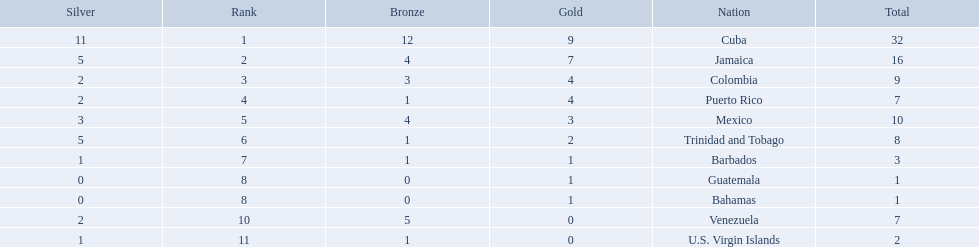Which 3 countries were awarded the most medals? Cuba, Jamaica, Colombia. Of these 3 countries which ones are islands? Cuba, Jamaica. Which one won the most silver medals? Cuba. Parse the table in full. {'header': ['Silver', 'Rank', 'Bronze', 'Gold', 'Nation', 'Total'], 'rows': [['11', '1', '12', '9', 'Cuba', '32'], ['5', '2', '4', '7', 'Jamaica', '16'], ['2', '3', '3', '4', 'Colombia', '9'], ['2', '4', '1', '4', 'Puerto Rico', '7'], ['3', '5', '4', '3', 'Mexico', '10'], ['5', '6', '1', '2', 'Trinidad and Tobago', '8'], ['1', '7', '1', '1', 'Barbados', '3'], ['0', '8', '0', '1', 'Guatemala', '1'], ['0', '8', '0', '1', 'Bahamas', '1'], ['2', '10', '5', '0', 'Venezuela', '7'], ['1', '11', '1', '0', 'U.S. Virgin Islands', '2']]} What teams had four gold medals? Colombia, Puerto Rico. Of these two, which team only had one bronze medal? Puerto Rico. 